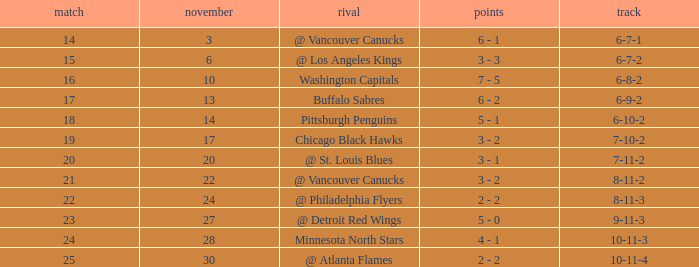Who is the opponent on november 24? @ Philadelphia Flyers. 